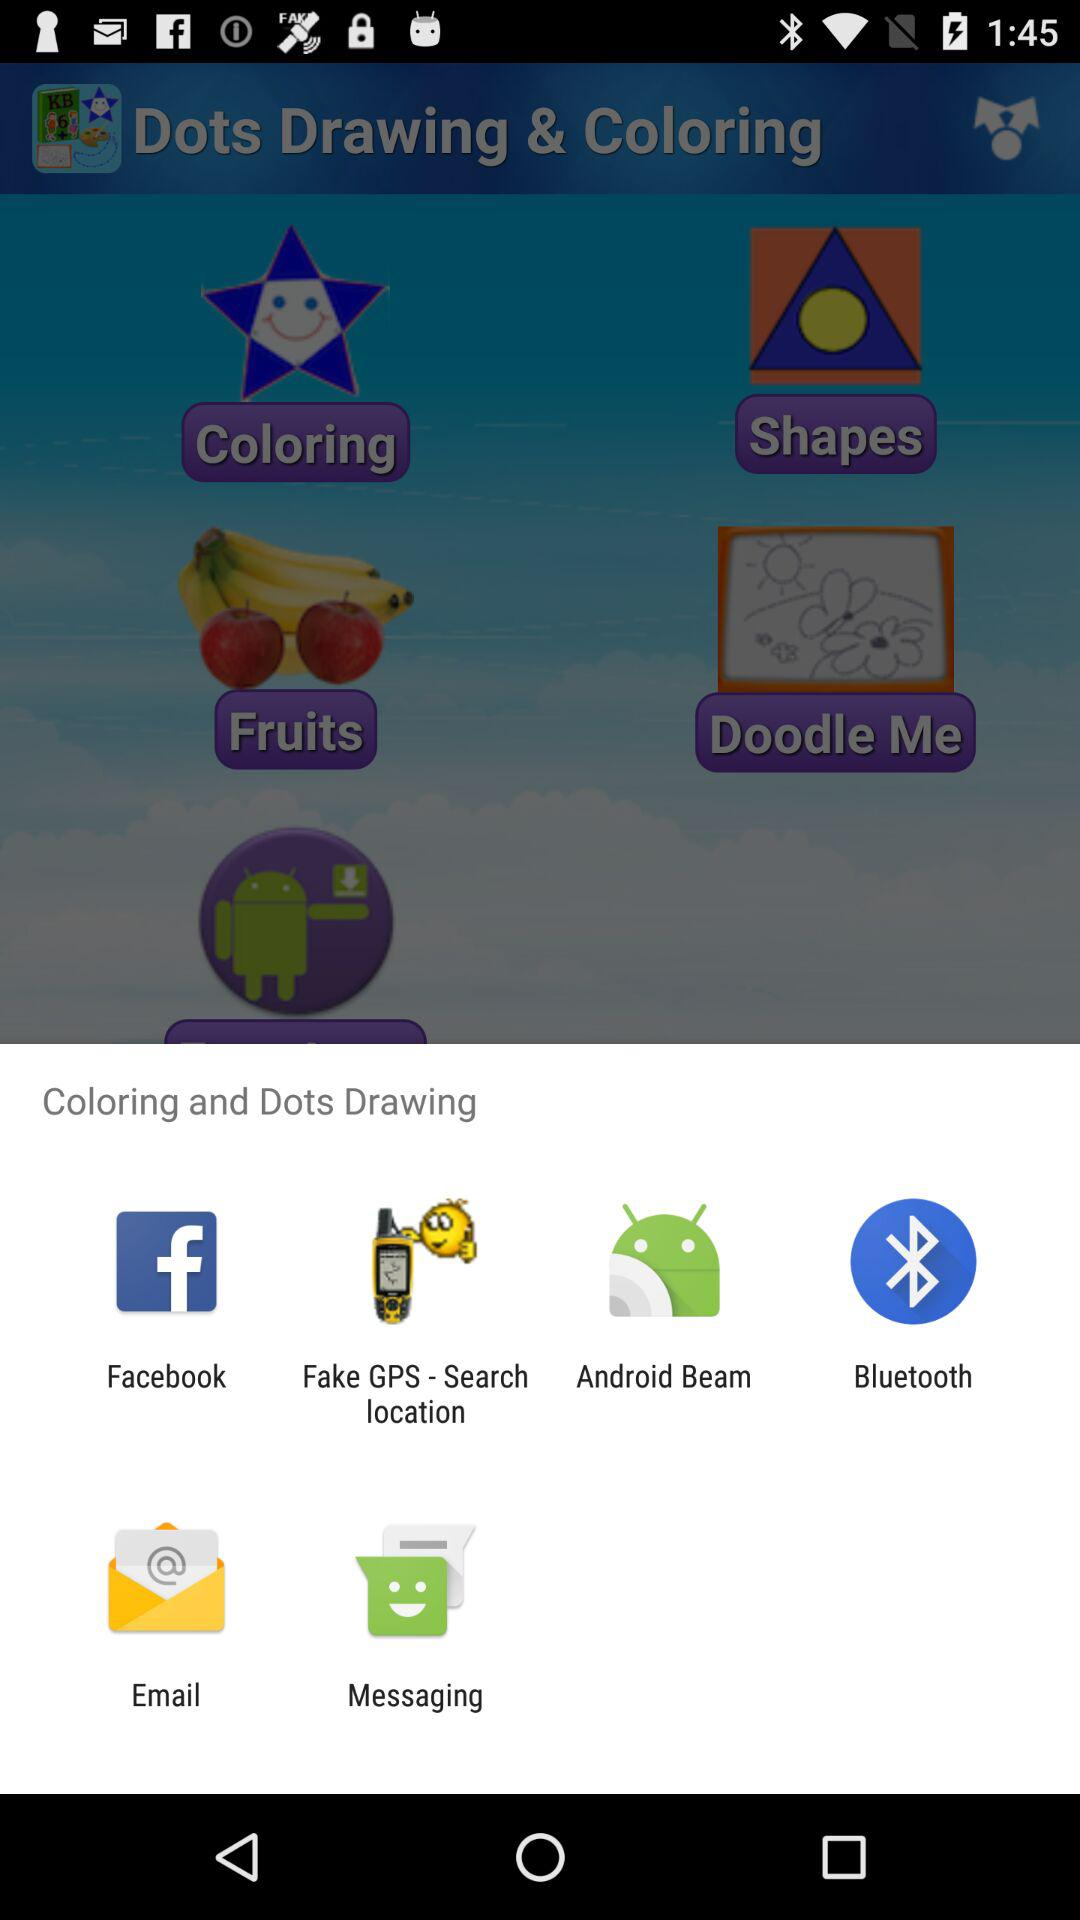What applications can be used for coloring and dots drawing? The applications are "Facebook", "Fake GPS - Search location", "Android Beam", "Bluetooth", "Email" and "Messaging". 